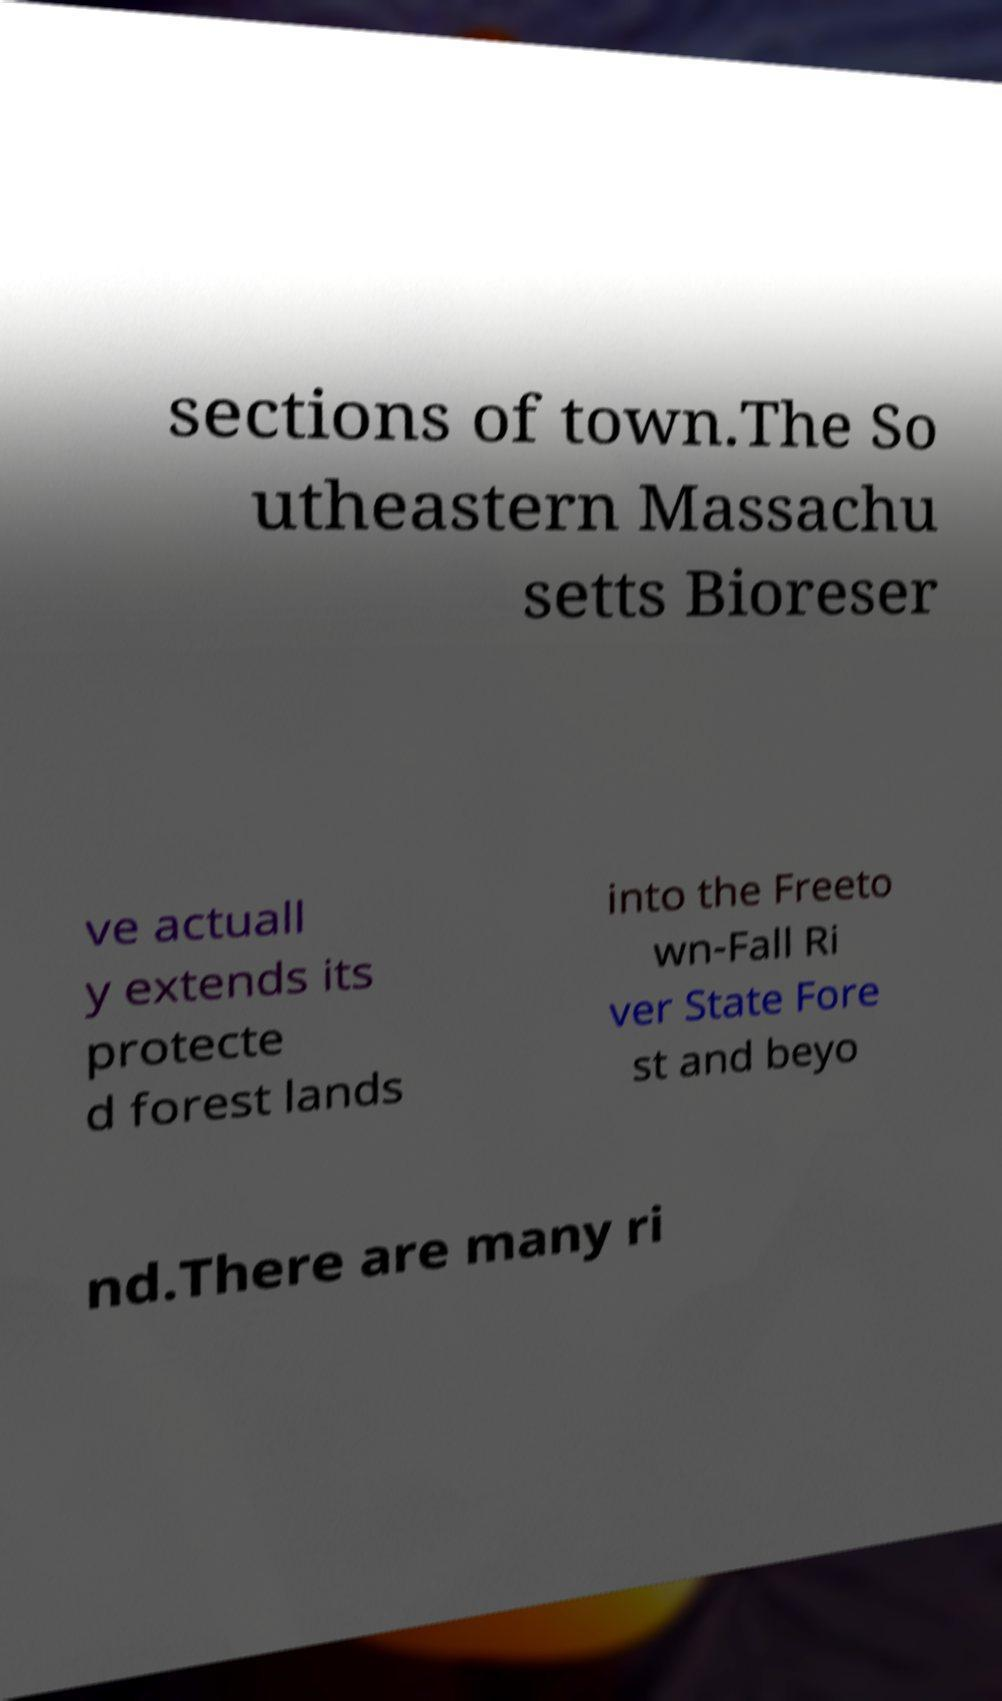What messages or text are displayed in this image? I need them in a readable, typed format. sections of town.The So utheastern Massachu setts Bioreser ve actuall y extends its protecte d forest lands into the Freeto wn-Fall Ri ver State Fore st and beyo nd.There are many ri 